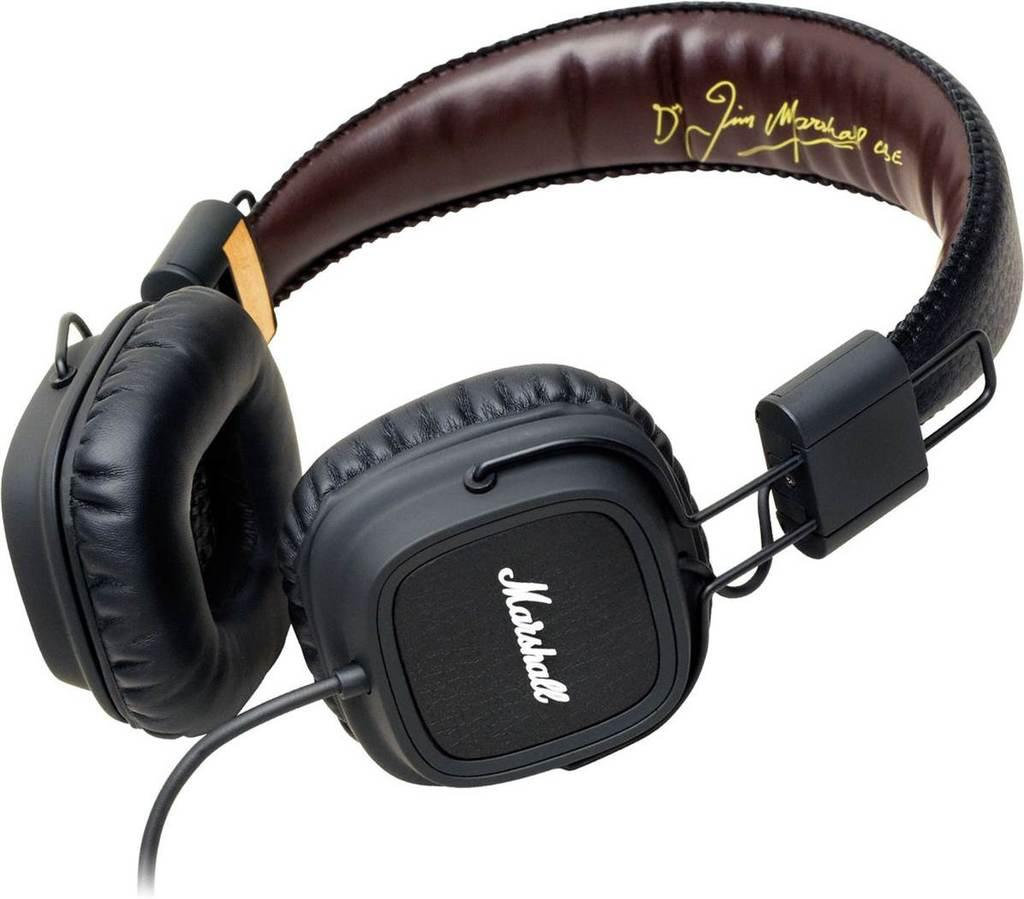What is the main object in the image? There are headphones in the image. What color is the background of the image? The background of the image is white. How many crayons are being used by the person in the image? There is no person present in the image, and therefore no crayons are being used. What shape is the heart in the image? There is no heart present in the image. 